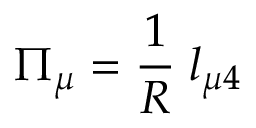Convert formula to latex. <formula><loc_0><loc_0><loc_500><loc_500>\Pi _ { \mu } = \frac { 1 } { R } \, l _ { \mu 4 }</formula> 